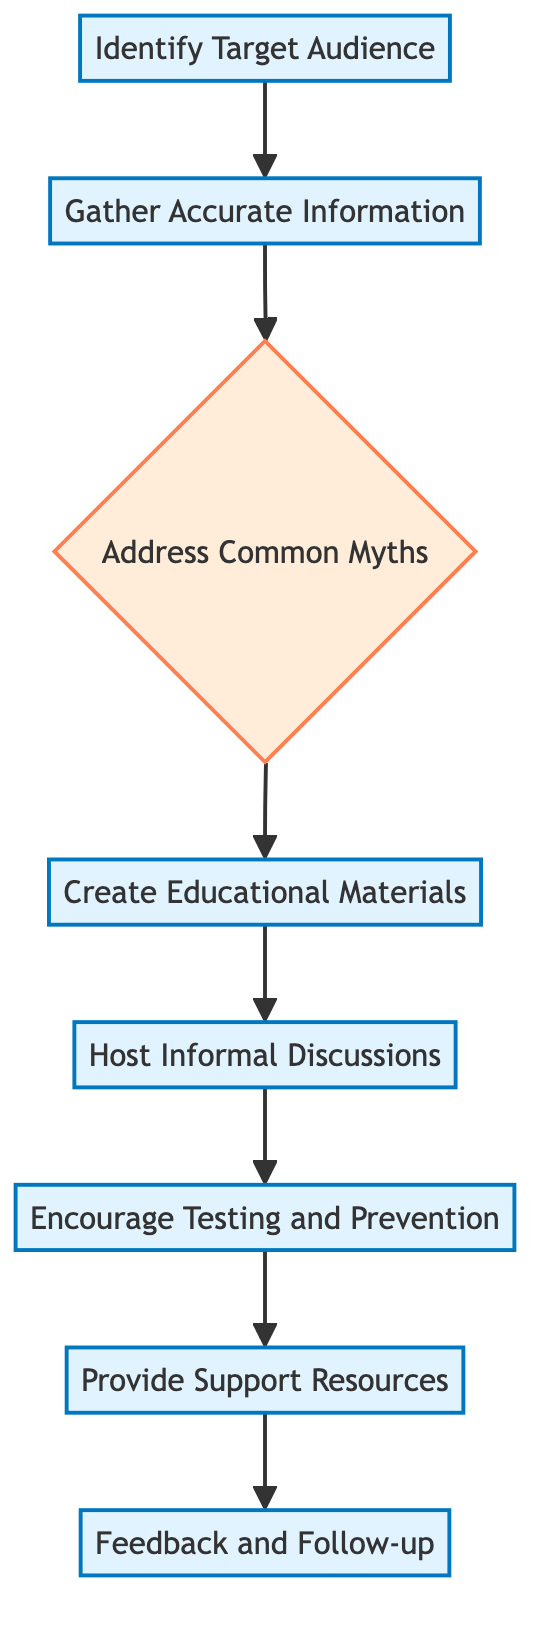What is the first step in the diagram? The diagram starts with the first node labeled "Identify Target Audience." This node is the initial action that leads to the next steps in HIV education.
Answer: Identify Target Audience How many total nodes are in the diagram? By counting each box in the diagram, there are eight distinct nodes representing different steps in the process.
Answer: Eight What does the second node focus on? The second node is titled "Gather Accurate Information," which indicates that the next step after identifying the audience is to collect reliable data about HIV.
Answer: Gather Accurate Information Which step comes after "Address Common Myths"? After addressing common myths, the diagram guides you to the next step labeled "Create Educational Materials." This shows the linear flow of actions following myth addressing.
Answer: Create Educational Materials What are the last two steps in the diagram? The final two steps are "Provide Support Resources" and "Feedback and Follow-up," indicating the conclusion of the educational process and the importance of ongoing communication.
Answer: Provide Support Resources, Feedback and Follow-up What is the relationship between "Host Informal Discussions" and "Encourage Testing and Prevention"? "Host Informal Discussions" leads directly to "Encourage Testing and Prevention," indicating that discussions should naturally progress to promoting testing and prevention strategies.
Answer: Host Informal Discussions -> Encourage Testing and Prevention Which node emphasizes the importance of available resources? The node titled "Provide Support Resources" specifically focuses on sharing contact information for local clinics and support organizations, highlighting the need for accessible help.
Answer: Provide Support Resources How many decision nodes are present in the flowchart? The diagram includes one decision node, which is labeled "Address Common Myths," indicating that this point requires evaluation before proceeding to the next steps.
Answer: One 